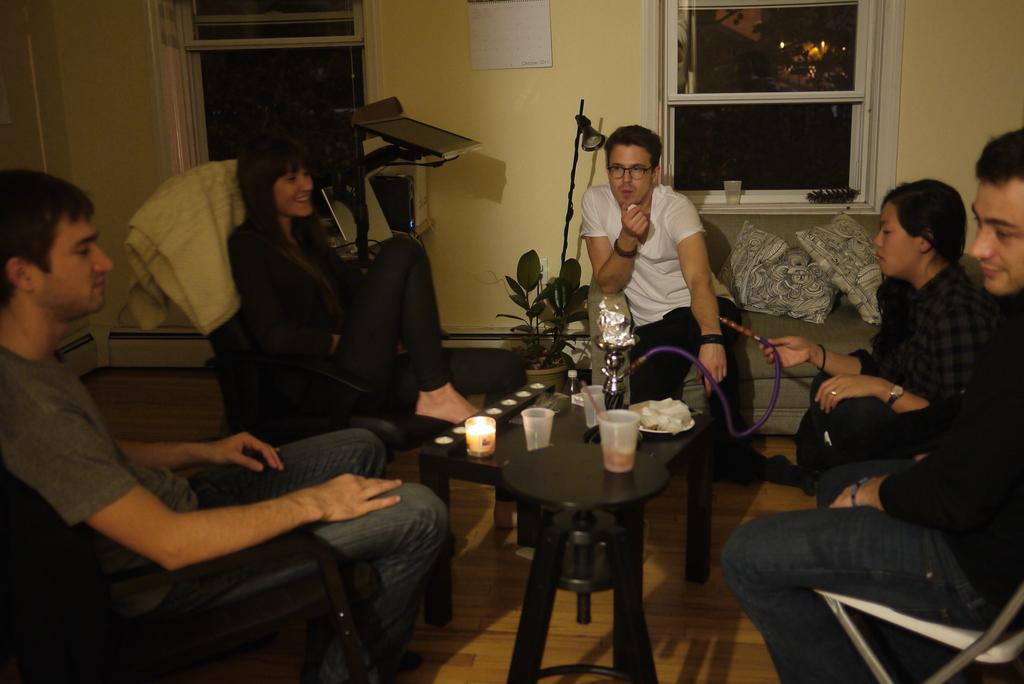How would you summarize this image in a sentence or two? In this picture we can see five people sitting on chair and sofa pillows on it and in front of them there is table and on table we can see glass, plate, candle and beside to them flower pot with plant, light and in background we can see windows, wall. 